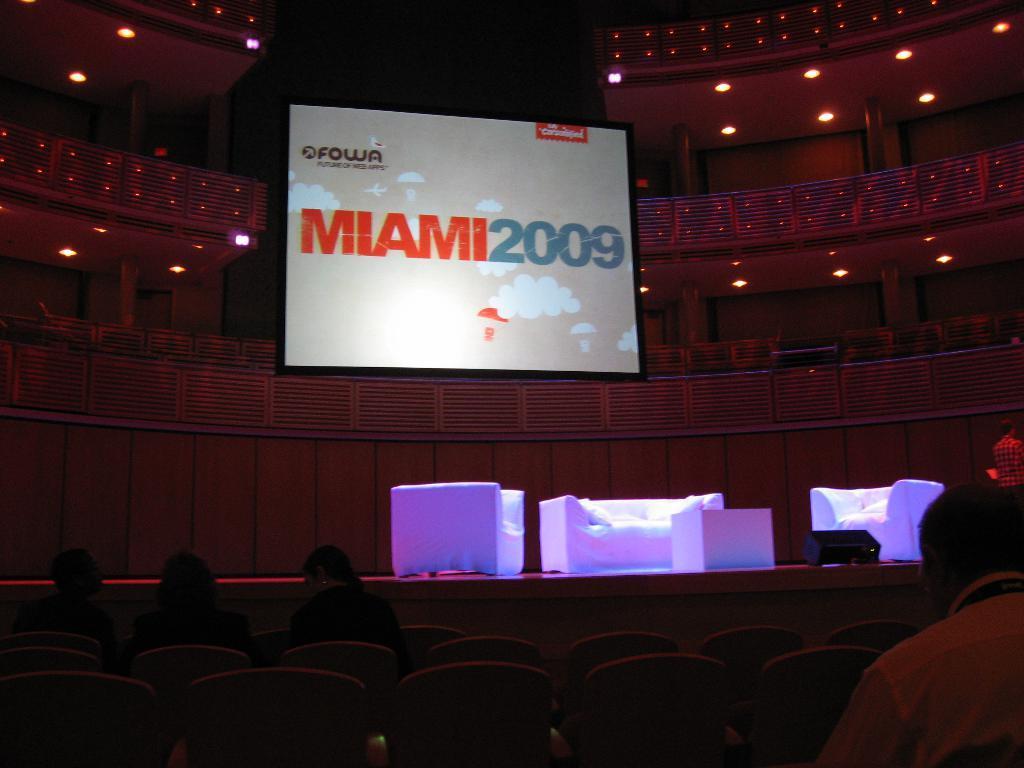Can you describe this image briefly? In the middle of this image I can see a couch, two chairs and a table which are placed on the stage. At the bottom of the image I can see few people are sitting on the chairs and facing towards the stage and also there are some empty chairs. In the background, I can see a screen which is attached to the wall. On the screen I can see some text. At the top there are some lights. 